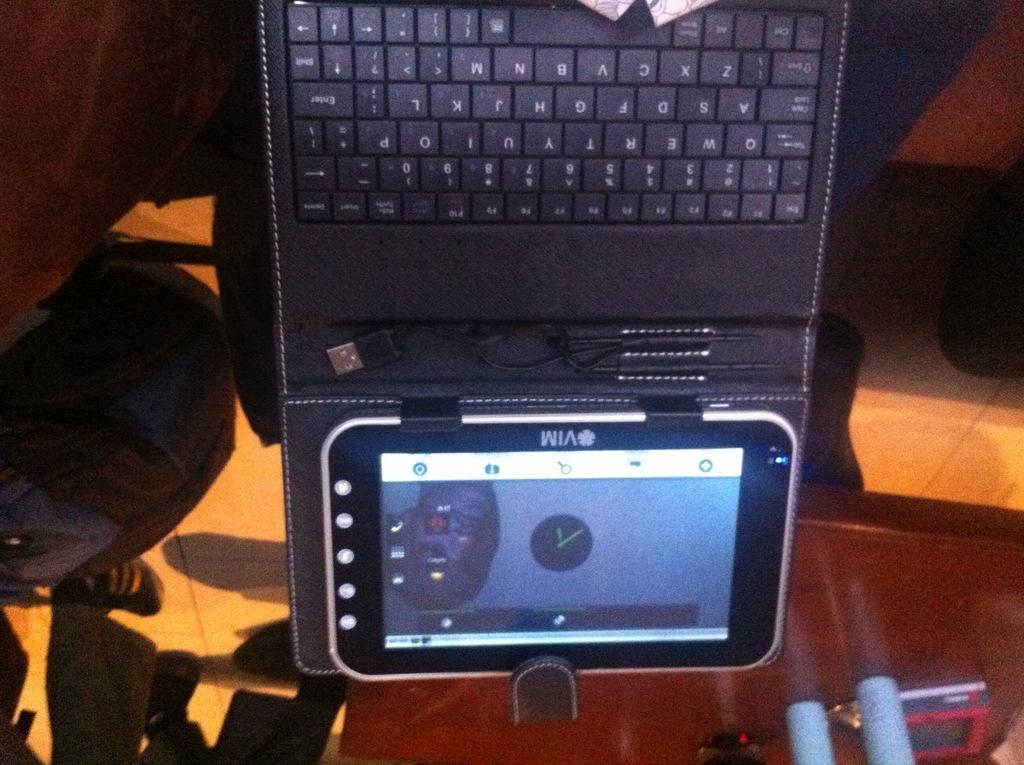What is the first letter on the keyboard?
Provide a short and direct response. Q. What brand is it?
Keep it short and to the point. Vim. 